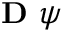<formula> <loc_0><loc_0><loc_500><loc_500>D \psi</formula> 